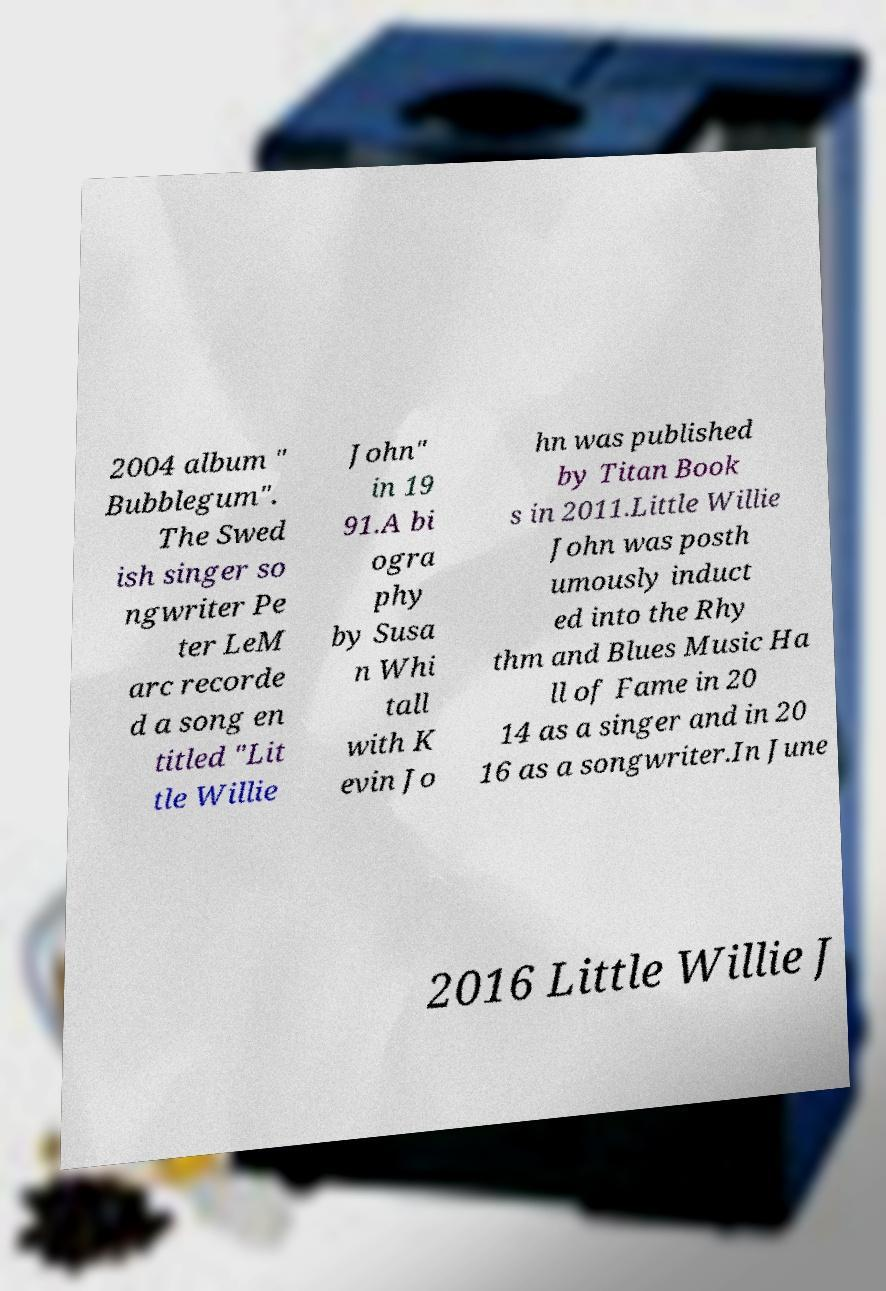There's text embedded in this image that I need extracted. Can you transcribe it verbatim? 2004 album " Bubblegum". The Swed ish singer so ngwriter Pe ter LeM arc recorde d a song en titled "Lit tle Willie John" in 19 91.A bi ogra phy by Susa n Whi tall with K evin Jo hn was published by Titan Book s in 2011.Little Willie John was posth umously induct ed into the Rhy thm and Blues Music Ha ll of Fame in 20 14 as a singer and in 20 16 as a songwriter.In June 2016 Little Willie J 